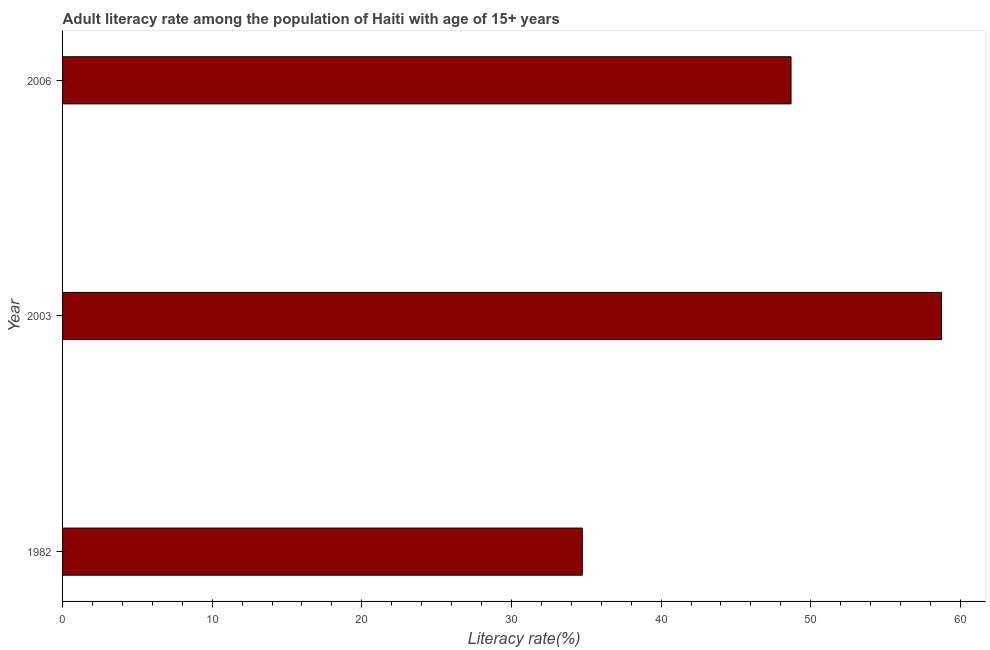What is the title of the graph?
Your answer should be compact. Adult literacy rate among the population of Haiti with age of 15+ years. What is the label or title of the X-axis?
Your response must be concise. Literacy rate(%). What is the adult literacy rate in 2006?
Give a very brief answer. 48.69. Across all years, what is the maximum adult literacy rate?
Ensure brevity in your answer.  58.74. Across all years, what is the minimum adult literacy rate?
Keep it short and to the point. 34.73. In which year was the adult literacy rate maximum?
Give a very brief answer. 2003. What is the sum of the adult literacy rate?
Offer a terse response. 142.16. What is the difference between the adult literacy rate in 1982 and 2003?
Give a very brief answer. -24.01. What is the average adult literacy rate per year?
Keep it short and to the point. 47.39. What is the median adult literacy rate?
Your response must be concise. 48.69. Do a majority of the years between 2003 and 2006 (inclusive) have adult literacy rate greater than 50 %?
Offer a very short reply. No. What is the ratio of the adult literacy rate in 2003 to that in 2006?
Offer a terse response. 1.21. What is the difference between the highest and the second highest adult literacy rate?
Your answer should be very brief. 10.06. Is the sum of the adult literacy rate in 1982 and 2003 greater than the maximum adult literacy rate across all years?
Your answer should be compact. Yes. What is the difference between the highest and the lowest adult literacy rate?
Your answer should be very brief. 24.01. How many bars are there?
Offer a very short reply. 3. Are all the bars in the graph horizontal?
Keep it short and to the point. Yes. What is the Literacy rate(%) of 1982?
Your response must be concise. 34.73. What is the Literacy rate(%) in 2003?
Ensure brevity in your answer.  58.74. What is the Literacy rate(%) of 2006?
Your response must be concise. 48.69. What is the difference between the Literacy rate(%) in 1982 and 2003?
Keep it short and to the point. -24.01. What is the difference between the Literacy rate(%) in 1982 and 2006?
Your answer should be very brief. -13.95. What is the difference between the Literacy rate(%) in 2003 and 2006?
Your answer should be very brief. 10.06. What is the ratio of the Literacy rate(%) in 1982 to that in 2003?
Provide a short and direct response. 0.59. What is the ratio of the Literacy rate(%) in 1982 to that in 2006?
Your answer should be compact. 0.71. What is the ratio of the Literacy rate(%) in 2003 to that in 2006?
Provide a short and direct response. 1.21. 